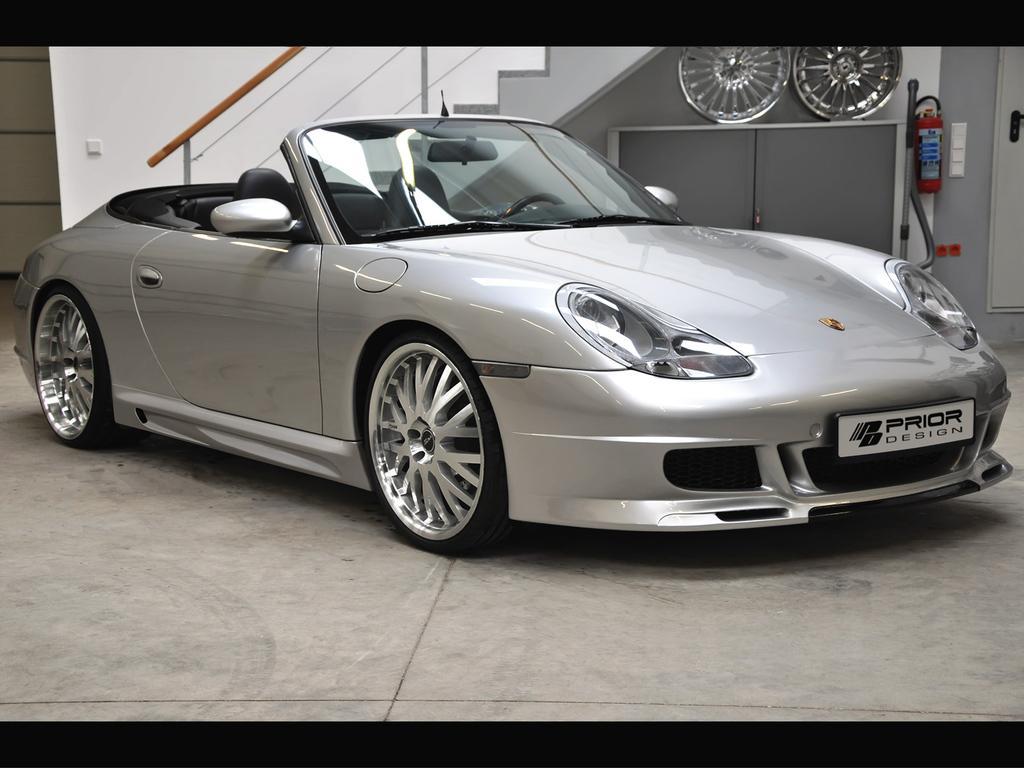In one or two sentences, can you explain what this image depicts? In this image, we can see a car in front of the wall. There is a staircase at the top of the image. There are wheels and extinguisher in the top right of the image. 